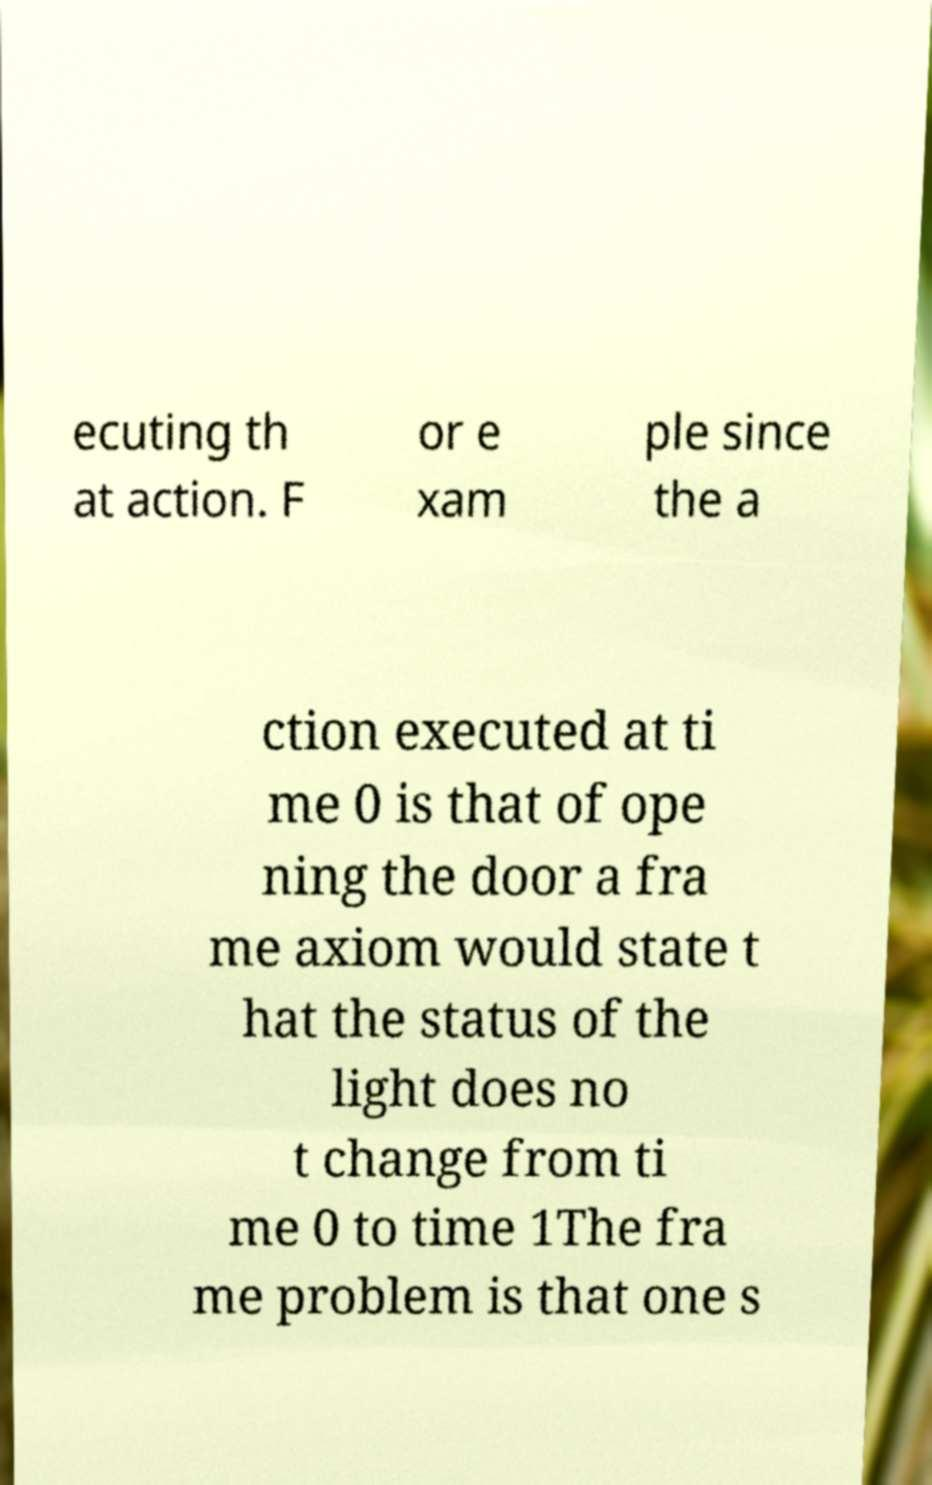Can you accurately transcribe the text from the provided image for me? ecuting th at action. F or e xam ple since the a ction executed at ti me 0 is that of ope ning the door a fra me axiom would state t hat the status of the light does no t change from ti me 0 to time 1The fra me problem is that one s 